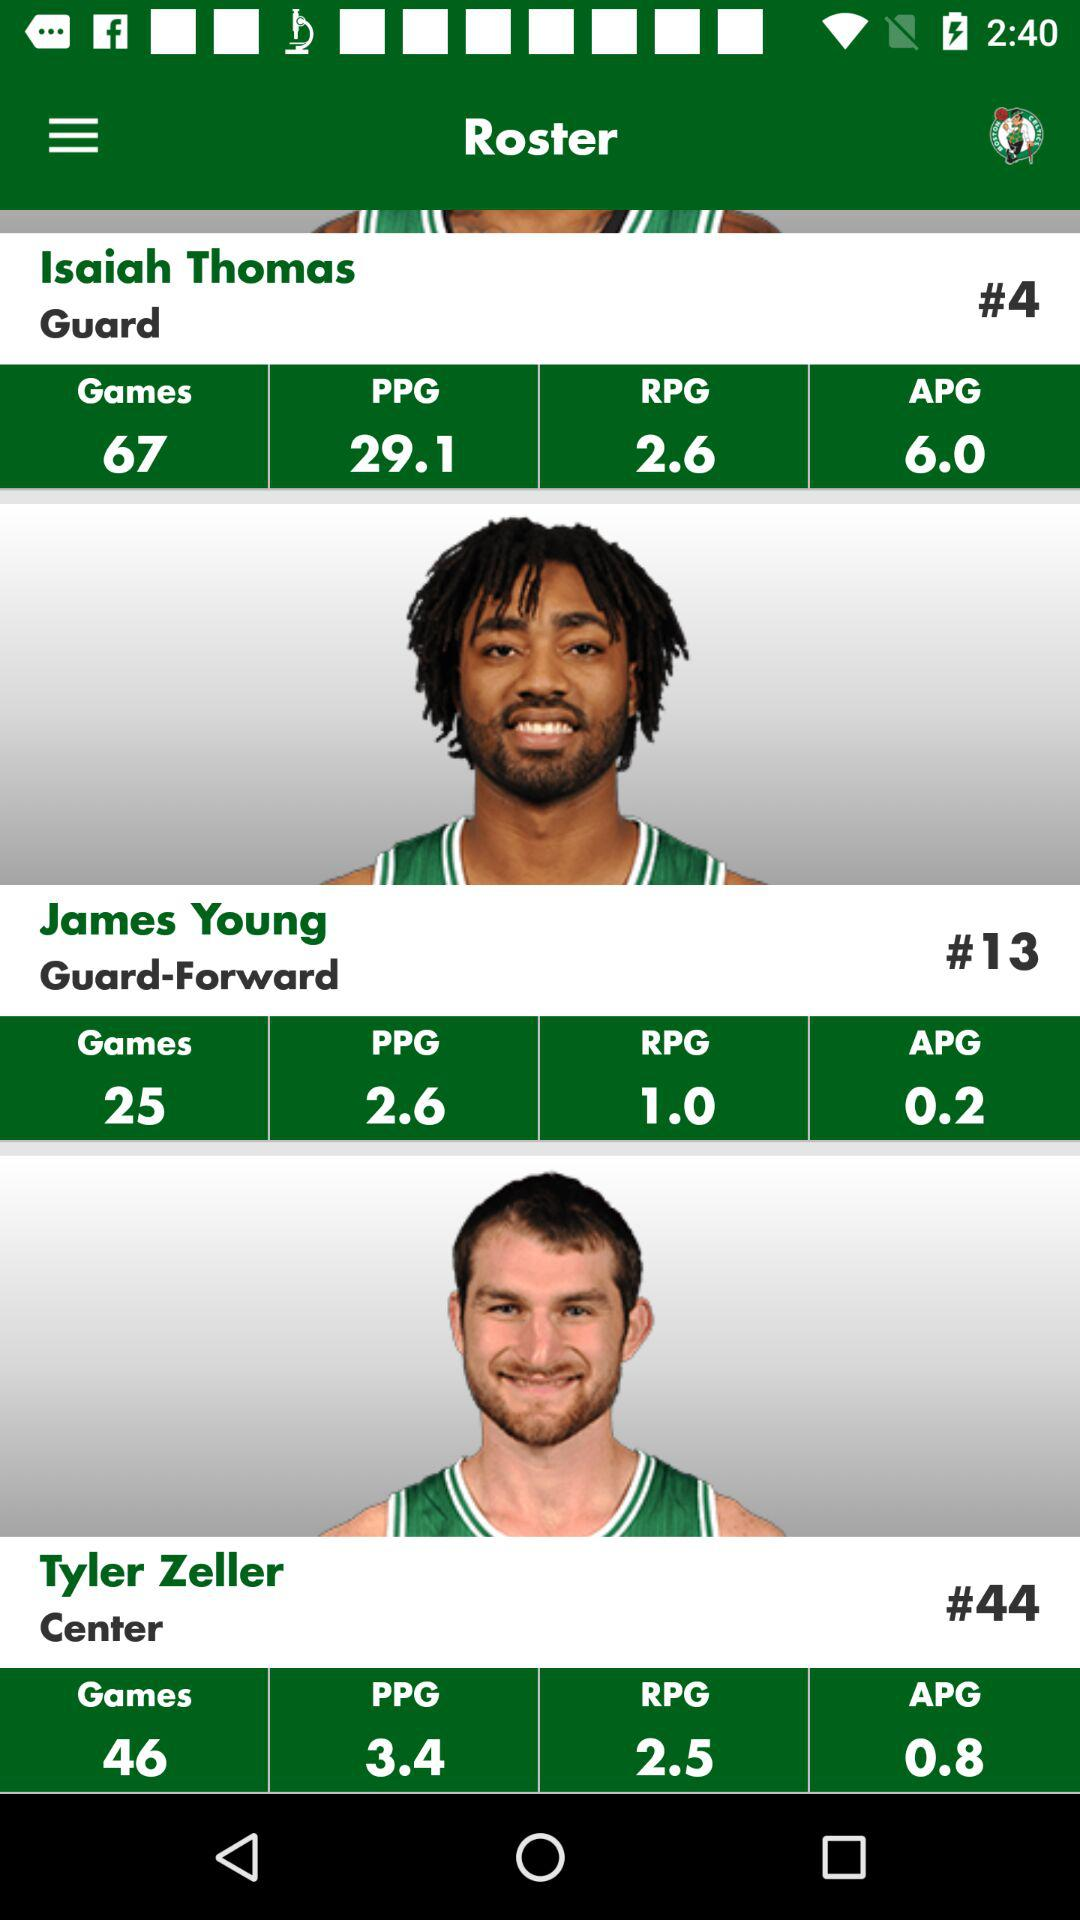What is the PPG point for Tyler Zeller? The PPG point for Tyler Zeller is 3.4. 